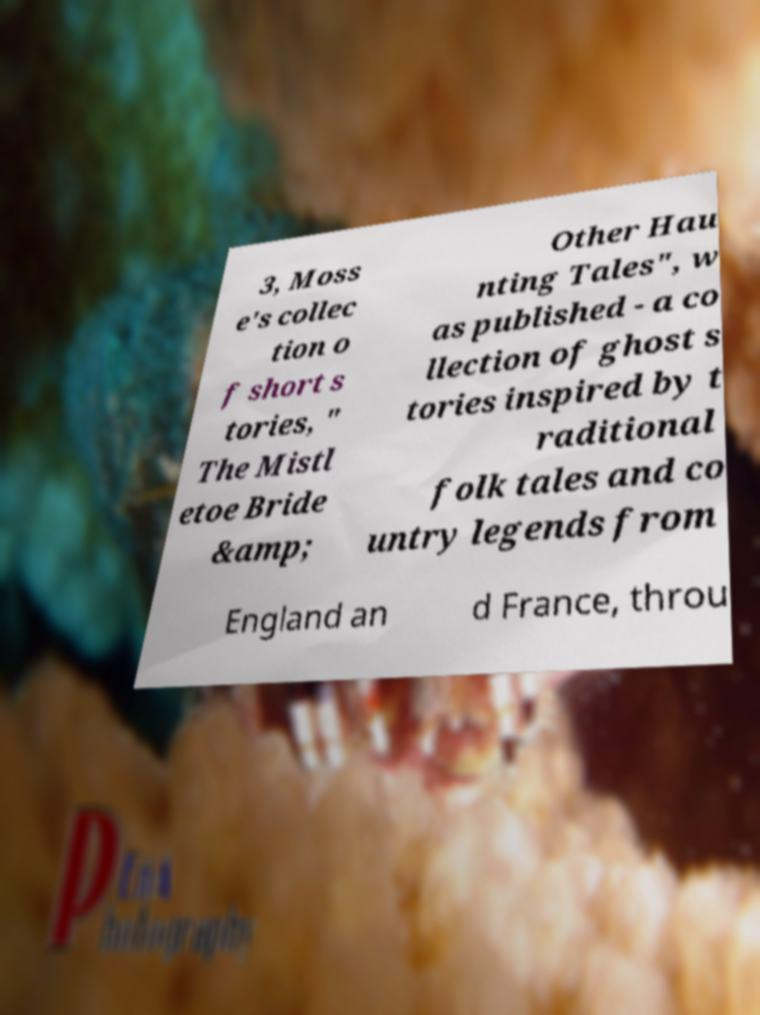Could you assist in decoding the text presented in this image and type it out clearly? 3, Moss e's collec tion o f short s tories, " The Mistl etoe Bride &amp; Other Hau nting Tales", w as published - a co llection of ghost s tories inspired by t raditional folk tales and co untry legends from England an d France, throu 